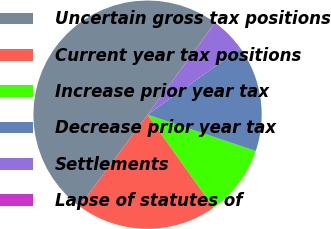<chart> <loc_0><loc_0><loc_500><loc_500><pie_chart><fcel>Uncertain gross tax positions<fcel>Current year tax positions<fcel>Increase prior year tax<fcel>Decrease prior year tax<fcel>Settlements<fcel>Lapse of statutes of<nl><fcel>49.91%<fcel>19.99%<fcel>10.02%<fcel>15.0%<fcel>5.03%<fcel>0.05%<nl></chart> 